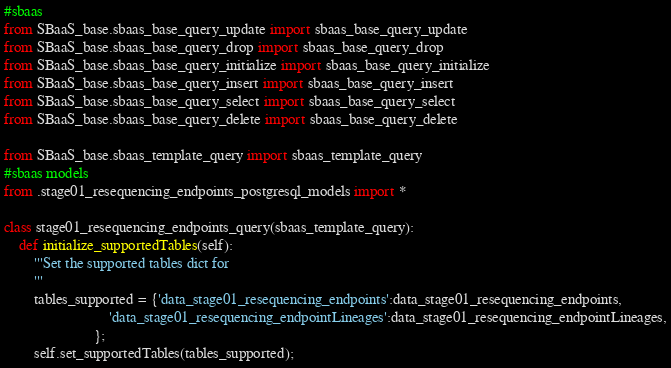Convert code to text. <code><loc_0><loc_0><loc_500><loc_500><_Python_>#sbaas
from SBaaS_base.sbaas_base_query_update import sbaas_base_query_update
from SBaaS_base.sbaas_base_query_drop import sbaas_base_query_drop
from SBaaS_base.sbaas_base_query_initialize import sbaas_base_query_initialize
from SBaaS_base.sbaas_base_query_insert import sbaas_base_query_insert
from SBaaS_base.sbaas_base_query_select import sbaas_base_query_select
from SBaaS_base.sbaas_base_query_delete import sbaas_base_query_delete

from SBaaS_base.sbaas_template_query import sbaas_template_query
#sbaas models
from .stage01_resequencing_endpoints_postgresql_models import *

class stage01_resequencing_endpoints_query(sbaas_template_query):
    def initialize_supportedTables(self):
        '''Set the supported tables dict for 
        '''
        tables_supported = {'data_stage01_resequencing_endpoints':data_stage01_resequencing_endpoints,
                            'data_stage01_resequencing_endpointLineages':data_stage01_resequencing_endpointLineages,
                        };
        self.set_supportedTables(tables_supported);</code> 